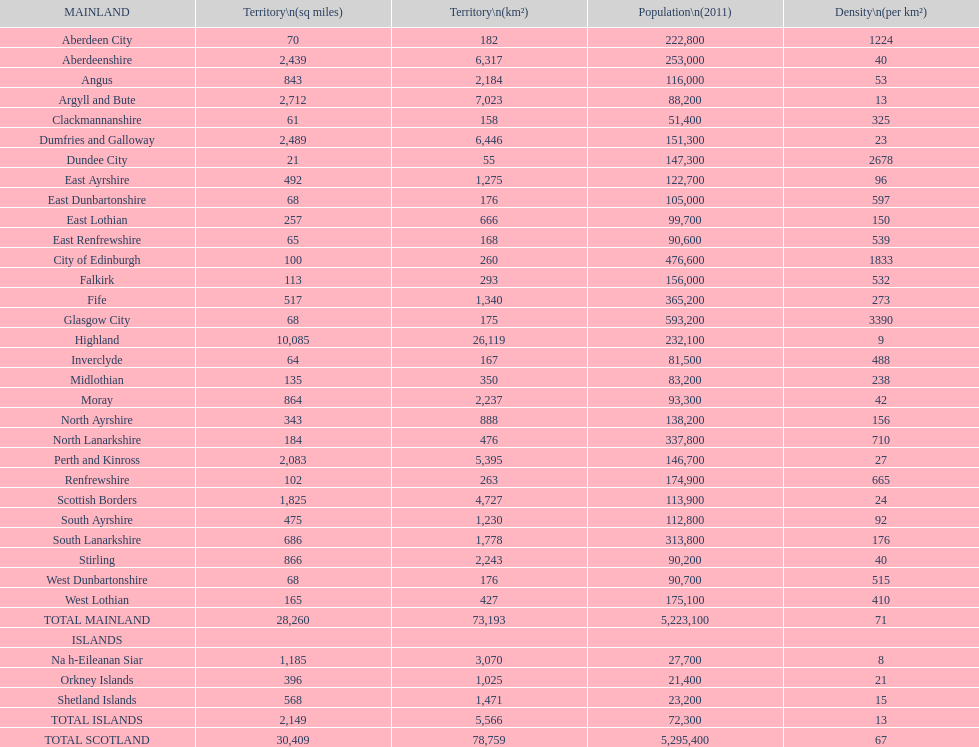Which is the only subdivision to have a greater area than argyll and bute? Highland. Parse the full table. {'header': ['MAINLAND', 'Territory\\n(sq miles)', 'Territory\\n(km²)', 'Population\\n(2011)', 'Density\\n(per km²)'], 'rows': [['Aberdeen City', '70', '182', '222,800', '1224'], ['Aberdeenshire', '2,439', '6,317', '253,000', '40'], ['Angus', '843', '2,184', '116,000', '53'], ['Argyll and Bute', '2,712', '7,023', '88,200', '13'], ['Clackmannanshire', '61', '158', '51,400', '325'], ['Dumfries and Galloway', '2,489', '6,446', '151,300', '23'], ['Dundee City', '21', '55', '147,300', '2678'], ['East Ayrshire', '492', '1,275', '122,700', '96'], ['East Dunbartonshire', '68', '176', '105,000', '597'], ['East Lothian', '257', '666', '99,700', '150'], ['East Renfrewshire', '65', '168', '90,600', '539'], ['City of Edinburgh', '100', '260', '476,600', '1833'], ['Falkirk', '113', '293', '156,000', '532'], ['Fife', '517', '1,340', '365,200', '273'], ['Glasgow City', '68', '175', '593,200', '3390'], ['Highland', '10,085', '26,119', '232,100', '9'], ['Inverclyde', '64', '167', '81,500', '488'], ['Midlothian', '135', '350', '83,200', '238'], ['Moray', '864', '2,237', '93,300', '42'], ['North Ayrshire', '343', '888', '138,200', '156'], ['North Lanarkshire', '184', '476', '337,800', '710'], ['Perth and Kinross', '2,083', '5,395', '146,700', '27'], ['Renfrewshire', '102', '263', '174,900', '665'], ['Scottish Borders', '1,825', '4,727', '113,900', '24'], ['South Ayrshire', '475', '1,230', '112,800', '92'], ['South Lanarkshire', '686', '1,778', '313,800', '176'], ['Stirling', '866', '2,243', '90,200', '40'], ['West Dunbartonshire', '68', '176', '90,700', '515'], ['West Lothian', '165', '427', '175,100', '410'], ['TOTAL MAINLAND', '28,260', '73,193', '5,223,100', '71'], ['ISLANDS', '', '', '', ''], ['Na h-Eileanan Siar', '1,185', '3,070', '27,700', '8'], ['Orkney Islands', '396', '1,025', '21,400', '21'], ['Shetland Islands', '568', '1,471', '23,200', '15'], ['TOTAL ISLANDS', '2,149', '5,566', '72,300', '13'], ['TOTAL SCOTLAND', '30,409', '78,759', '5,295,400', '67']]} 